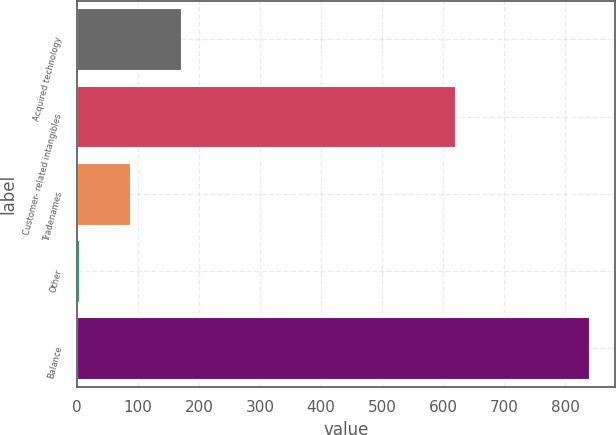Convert chart to OTSL. <chart><loc_0><loc_0><loc_500><loc_500><bar_chart><fcel>Acquired technology<fcel>Customer- related intangibles<fcel>Tradenames<fcel>Other<fcel>Balance<nl><fcel>171.2<fcel>620<fcel>87.6<fcel>4<fcel>840<nl></chart> 